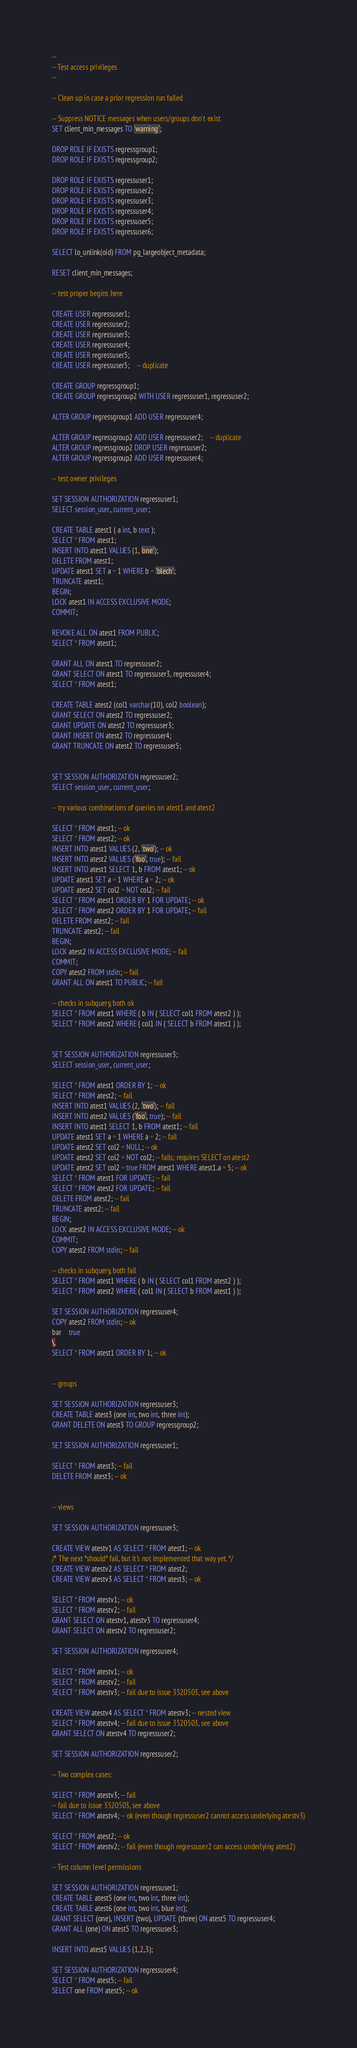<code> <loc_0><loc_0><loc_500><loc_500><_SQL_>--
-- Test access privileges
--

-- Clean up in case a prior regression run failed

-- Suppress NOTICE messages when users/groups don't exist
SET client_min_messages TO 'warning';

DROP ROLE IF EXISTS regressgroup1;
DROP ROLE IF EXISTS regressgroup2;

DROP ROLE IF EXISTS regressuser1;
DROP ROLE IF EXISTS regressuser2;
DROP ROLE IF EXISTS regressuser3;
DROP ROLE IF EXISTS regressuser4;
DROP ROLE IF EXISTS regressuser5;
DROP ROLE IF EXISTS regressuser6;

SELECT lo_unlink(oid) FROM pg_largeobject_metadata;

RESET client_min_messages;

-- test proper begins here

CREATE USER regressuser1;
CREATE USER regressuser2;
CREATE USER regressuser3;
CREATE USER regressuser4;
CREATE USER regressuser5;
CREATE USER regressuser5;	-- duplicate

CREATE GROUP regressgroup1;
CREATE GROUP regressgroup2 WITH USER regressuser1, regressuser2;

ALTER GROUP regressgroup1 ADD USER regressuser4;

ALTER GROUP regressgroup2 ADD USER regressuser2;	-- duplicate
ALTER GROUP regressgroup2 DROP USER regressuser2;
ALTER GROUP regressgroup2 ADD USER regressuser4;

-- test owner privileges

SET SESSION AUTHORIZATION regressuser1;
SELECT session_user, current_user;

CREATE TABLE atest1 ( a int, b text );
SELECT * FROM atest1;
INSERT INTO atest1 VALUES (1, 'one');
DELETE FROM atest1;
UPDATE atest1 SET a = 1 WHERE b = 'blech';
TRUNCATE atest1;
BEGIN;
LOCK atest1 IN ACCESS EXCLUSIVE MODE;
COMMIT;

REVOKE ALL ON atest1 FROM PUBLIC;
SELECT * FROM atest1;

GRANT ALL ON atest1 TO regressuser2;
GRANT SELECT ON atest1 TO regressuser3, regressuser4;
SELECT * FROM atest1;

CREATE TABLE atest2 (col1 varchar(10), col2 boolean);
GRANT SELECT ON atest2 TO regressuser2;
GRANT UPDATE ON atest2 TO regressuser3;
GRANT INSERT ON atest2 TO regressuser4;
GRANT TRUNCATE ON atest2 TO regressuser5;


SET SESSION AUTHORIZATION regressuser2;
SELECT session_user, current_user;

-- try various combinations of queries on atest1 and atest2

SELECT * FROM atest1; -- ok
SELECT * FROM atest2; -- ok
INSERT INTO atest1 VALUES (2, 'two'); -- ok
INSERT INTO atest2 VALUES ('foo', true); -- fail
INSERT INTO atest1 SELECT 1, b FROM atest1; -- ok
UPDATE atest1 SET a = 1 WHERE a = 2; -- ok
UPDATE atest2 SET col2 = NOT col2; -- fail
SELECT * FROM atest1 ORDER BY 1 FOR UPDATE; -- ok
SELECT * FROM atest2 ORDER BY 1 FOR UPDATE; -- fail
DELETE FROM atest2; -- fail
TRUNCATE atest2; -- fail
BEGIN;
LOCK atest2 IN ACCESS EXCLUSIVE MODE; -- fail
COMMIT;
COPY atest2 FROM stdin; -- fail
GRANT ALL ON atest1 TO PUBLIC; -- fail

-- checks in subquery, both ok
SELECT * FROM atest1 WHERE ( b IN ( SELECT col1 FROM atest2 ) );
SELECT * FROM atest2 WHERE ( col1 IN ( SELECT b FROM atest1 ) );


SET SESSION AUTHORIZATION regressuser3;
SELECT session_user, current_user;

SELECT * FROM atest1 ORDER BY 1; -- ok
SELECT * FROM atest2; -- fail
INSERT INTO atest1 VALUES (2, 'two'); -- fail
INSERT INTO atest2 VALUES ('foo', true); -- fail
INSERT INTO atest1 SELECT 1, b FROM atest1; -- fail
UPDATE atest1 SET a = 1 WHERE a = 2; -- fail
UPDATE atest2 SET col2 = NULL; -- ok
UPDATE atest2 SET col2 = NOT col2; -- fails; requires SELECT on atest2
UPDATE atest2 SET col2 = true FROM atest1 WHERE atest1.a = 5; -- ok
SELECT * FROM atest1 FOR UPDATE; -- fail
SELECT * FROM atest2 FOR UPDATE; -- fail
DELETE FROM atest2; -- fail
TRUNCATE atest2; -- fail
BEGIN;
LOCK atest2 IN ACCESS EXCLUSIVE MODE; -- ok
COMMIT;
COPY atest2 FROM stdin; -- fail

-- checks in subquery, both fail
SELECT * FROM atest1 WHERE ( b IN ( SELECT col1 FROM atest2 ) );
SELECT * FROM atest2 WHERE ( col1 IN ( SELECT b FROM atest1 ) );

SET SESSION AUTHORIZATION regressuser4;
COPY atest2 FROM stdin; -- ok
bar	true
\.
SELECT * FROM atest1 ORDER BY 1; -- ok


-- groups

SET SESSION AUTHORIZATION regressuser3;
CREATE TABLE atest3 (one int, two int, three int);
GRANT DELETE ON atest3 TO GROUP regressgroup2;

SET SESSION AUTHORIZATION regressuser1;

SELECT * FROM atest3; -- fail
DELETE FROM atest3; -- ok


-- views

SET SESSION AUTHORIZATION regressuser3;

CREATE VIEW atestv1 AS SELECT * FROM atest1; -- ok
/* The next *should* fail, but it's not implemented that way yet. */
CREATE VIEW atestv2 AS SELECT * FROM atest2;
CREATE VIEW atestv3 AS SELECT * FROM atest3; -- ok

SELECT * FROM atestv1; -- ok
SELECT * FROM atestv2; -- fail
GRANT SELECT ON atestv1, atestv3 TO regressuser4;
GRANT SELECT ON atestv2 TO regressuser2;

SET SESSION AUTHORIZATION regressuser4;

SELECT * FROM atestv1; -- ok
SELECT * FROM atestv2; -- fail
SELECT * FROM atestv3; -- fail due to issue 3520503, see above

CREATE VIEW atestv4 AS SELECT * FROM atestv3; -- nested view
SELECT * FROM atestv4; -- fail due to issue 3520503, see above
GRANT SELECT ON atestv4 TO regressuser2;

SET SESSION AUTHORIZATION regressuser2;

-- Two complex cases:

SELECT * FROM atestv3; -- fail
-- fail due to issue 3520503, see above
SELECT * FROM atestv4; -- ok (even though regressuser2 cannot access underlying atestv3)

SELECT * FROM atest2; -- ok
SELECT * FROM atestv2; -- fail (even though regressuser2 can access underlying atest2)

-- Test column level permissions

SET SESSION AUTHORIZATION regressuser1;
CREATE TABLE atest5 (one int, two int, three int);
CREATE TABLE atest6 (one int, two int, blue int);
GRANT SELECT (one), INSERT (two), UPDATE (three) ON atest5 TO regressuser4;
GRANT ALL (one) ON atest5 TO regressuser3;

INSERT INTO atest5 VALUES (1,2,3);

SET SESSION AUTHORIZATION regressuser4;
SELECT * FROM atest5; -- fail
SELECT one FROM atest5; -- ok</code> 